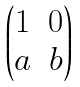Convert formula to latex. <formula><loc_0><loc_0><loc_500><loc_500>\begin{pmatrix} 1 & 0 \\ a & b \end{pmatrix}</formula> 